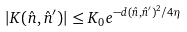<formula> <loc_0><loc_0><loc_500><loc_500>| K ( \hat { n } , \hat { n } ^ { \prime } ) | \leq K _ { 0 } e ^ { - d ( \hat { n } , \hat { n } ^ { \prime } ) ^ { 2 } / 4 \eta }</formula> 